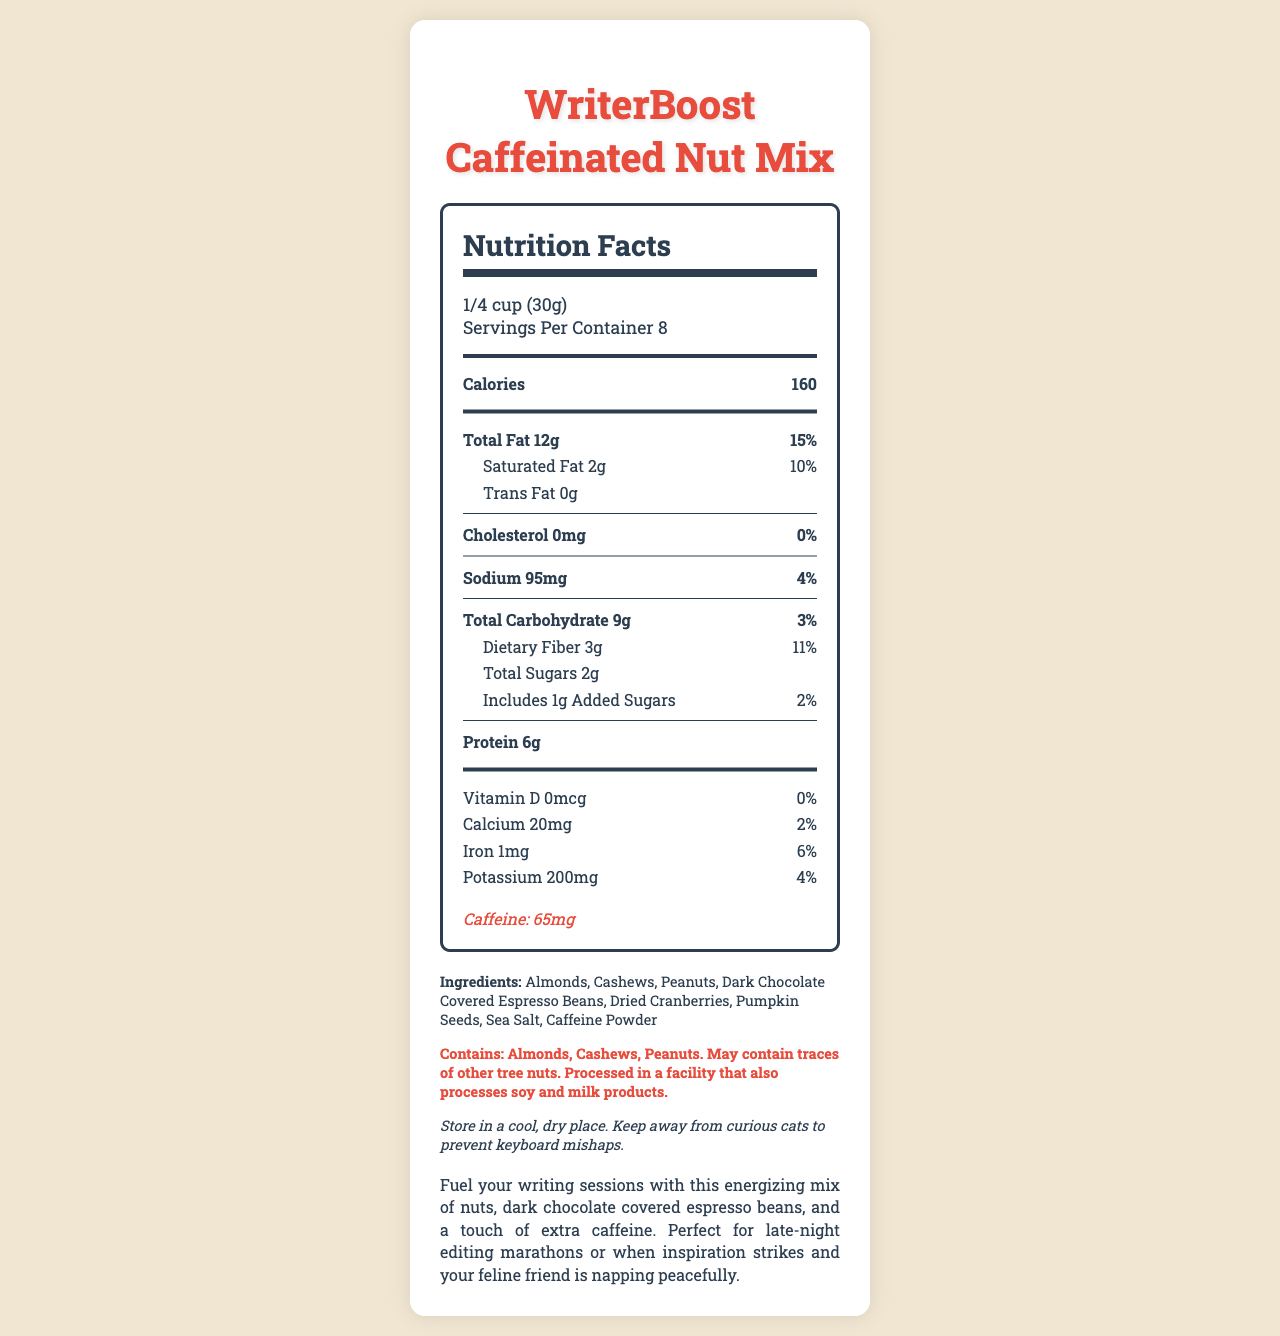What is the serving size of WriterBoost Caffeinated Nut Mix? The serving size information is displayed near the top of the nutrition facts section.
Answer: 1/4 cup (30g) How many servings are in one container of WriterBoost Caffeinated Nut Mix? The number of servings per container is listed in the serving info section.
Answer: 8 What is the total fat content per serving? The total fat amount is detailed in the main nutrient section under "Total Fat."
Answer: 12g What is the daily value percentage of saturated fat? The daily value percentage for saturated fat is given in the sub-nutrient section under "Saturated Fat."
Answer: 10% How much caffeine is in one serving of WriterBoost Caffeinated Nut Mix? The caffeine content is stated at the bottom of the nutrition label section.
Answer: 65mg What are the ingredients of WriterBoost Caffeinated Nut Mix? The ingredients list is provided below the nutrition facts, under the "Ingredients" heading.
Answer: Almonds, Cashews, Peanuts, Dark Chocolate Covered Espresso Beans, Dried Cranberries, Pumpkin Seeds, Sea Salt, Caffeine Powder What is the protein content per serving, and how is it beneficial for writers? The protein content per serving is shown in the main nutrient section for "Protein." Protein is beneficial as it helps maintain energy levels and focus.
Answer: 6g Which of the following nutrients does NOT contribute to daily value percentages? A. Vitamin D B. Iron C. Protein D. Added Sugars Protein does not have a daily value percentage listed; Vitamin D, Iron, and Added Sugars do.
Answer: C. Protein What is the sodium content in one serving? A. 200mg B. 95mg C. 30g D. 160mg Sodium content is listed under the main nutrient section for "Sodium."
Answer: B. 95mg Is there any cholesterol in WriterBoost Caffeinated Nut Mix? The cholesterol amount is listed as 0mg, indicating no cholesterol per serving.
Answer: No Does WriterBoost Caffeinated Nut Mix contain any added sugars? The nutrition label shows 1g of added sugars included under "Includes Added Sugars."
Answer: Yes Summarize the overall intent and contents of the WriterBoost Caffeinated Nut Mix. WriterBoost Caffeinated Nut Mix aims to provide an energy-boosting snack suitable for writers, packed with nuts and chocolate for taste, nutrients for sustenance, and caffeine for an extra boost. The document outlines the nutrition facts, ingredients, and special notes about allergens and storage.
Answer: WriterBoost Caffeinated Nut Mix is a nutritious snack designed to fuel writing sessions, combining various nuts, dark chocolate covered espresso beans, and extra caffeine. It provides energy with 160 calories per serving and contains key nutrients like protein and dietary fiber. Each serving includes a significant caffeine boost to enhance alertness. The product also lists ingredients, allergen information, and storage instructions. What manufacturing company produces WriterBoost Caffeinated Nut Mix? The manufacturer "WriterFuel Snacks, Inc." isn't visually indicated in the provided details of the Nutrition Facts Label and requires external or additional information to verify.
Answer: Cannot be determined Is WriterBoost Caffeinated Nut Mix suitable for individuals with nut allergies? The allergen information clearly states that it contains almonds, cashews, peanuts, and may contain traces of other tree nuts.
Answer: No 